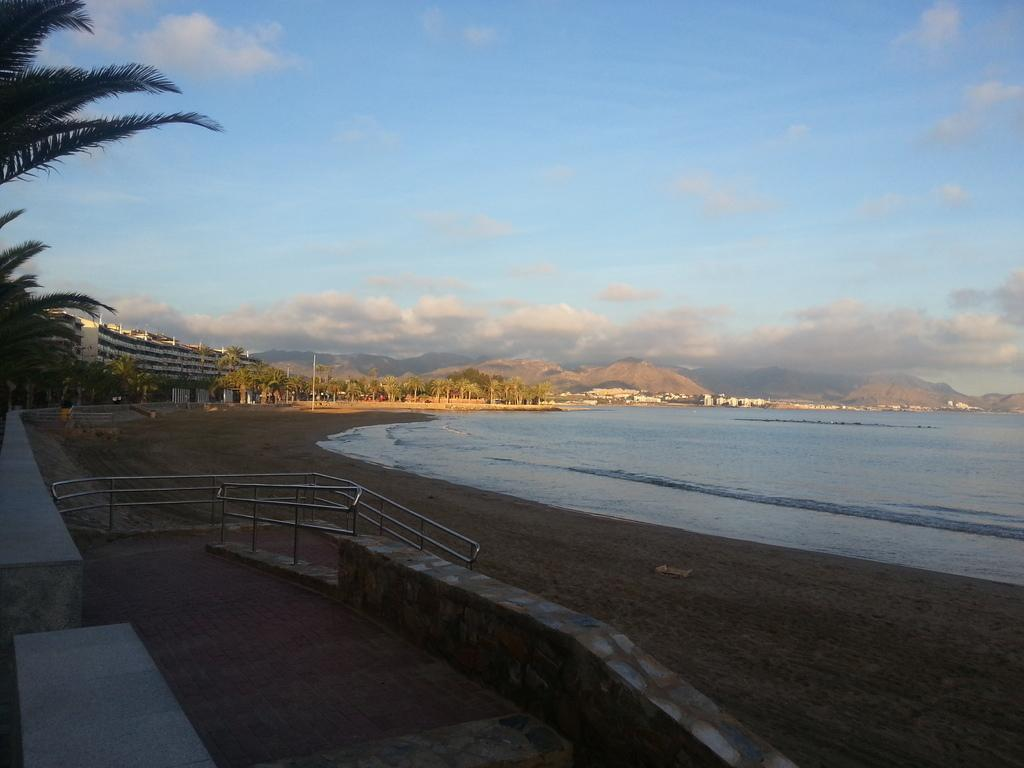What type of pathways can be seen in the image? There are walkways in the image. What type of railings are present along the walkways? There are rod railings in the image. What type of structure can be seen in the image? There is a wall in the image. What type of surface is visible in the image? There is ground visible in the image. What type of natural feature can be seen in the image? There is water visible in the image. What type of vegetation can be seen in the background of the image? In the background, there are trees. What type of man-made structures can be seen in the background of the image? In the background, there are poles and buildings. What type of geological feature can be seen in the background of the image? In the background, there are hills. What is the condition of the sky in the background of the image? The sky is cloudy in the background. Can you tell me how many loaves of bread are being carried by the mother in the image? There is no mother or loaves of bread present in the image. What type of group activity is happening in the image? There is no group activity depicted in the image. 